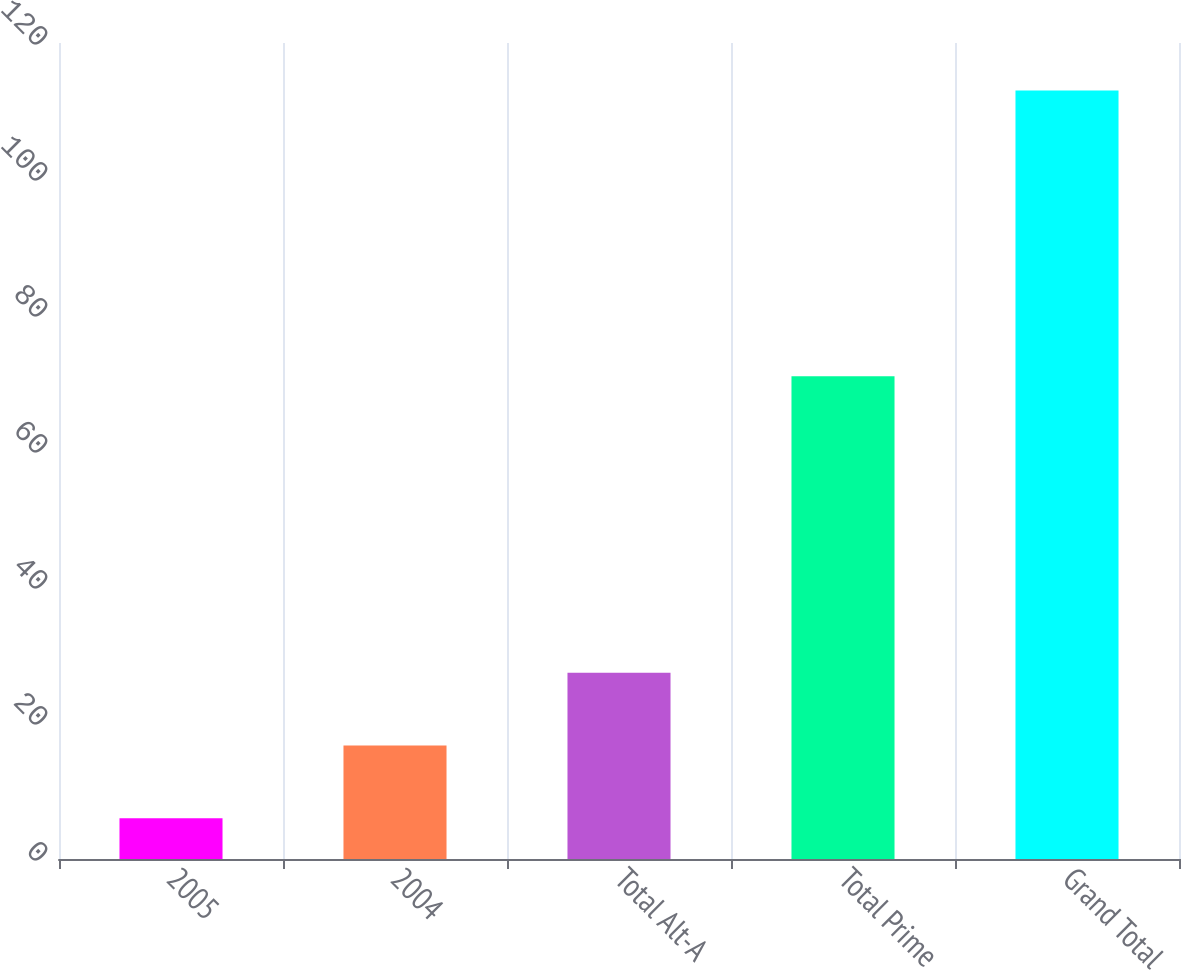<chart> <loc_0><loc_0><loc_500><loc_500><bar_chart><fcel>2005<fcel>2004<fcel>Total Alt-A<fcel>Total Prime<fcel>Grand Total<nl><fcel>6<fcel>16.7<fcel>27.4<fcel>71<fcel>113<nl></chart> 